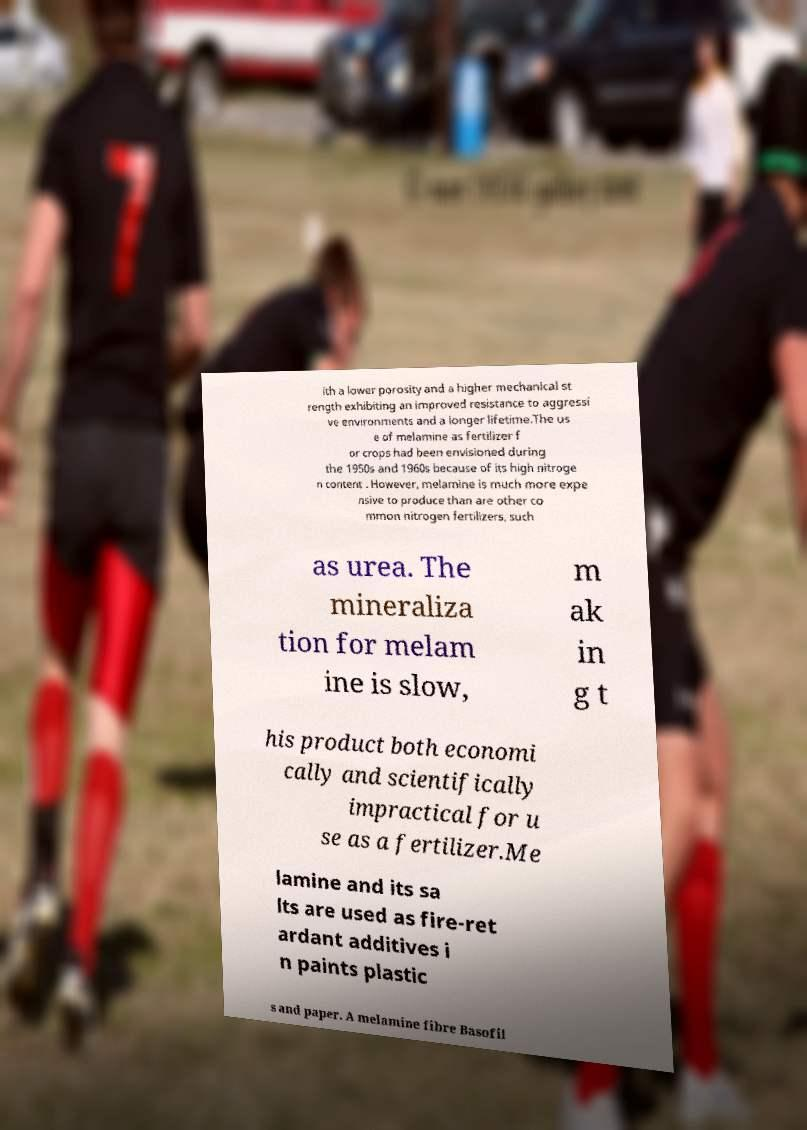Could you assist in decoding the text presented in this image and type it out clearly? ith a lower porosity and a higher mechanical st rength exhibiting an improved resistance to aggressi ve environments and a longer lifetime.The us e of melamine as fertilizer f or crops had been envisioned during the 1950s and 1960s because of its high nitroge n content . However, melamine is much more expe nsive to produce than are other co mmon nitrogen fertilizers, such as urea. The mineraliza tion for melam ine is slow, m ak in g t his product both economi cally and scientifically impractical for u se as a fertilizer.Me lamine and its sa lts are used as fire-ret ardant additives i n paints plastic s and paper. A melamine fibre Basofil 